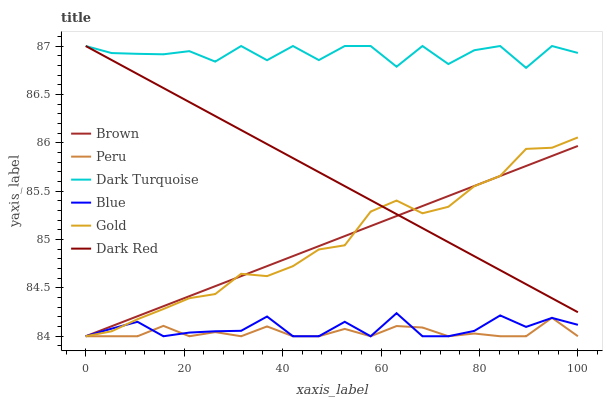Does Peru have the minimum area under the curve?
Answer yes or no. Yes. Does Dark Turquoise have the maximum area under the curve?
Answer yes or no. Yes. Does Brown have the minimum area under the curve?
Answer yes or no. No. Does Brown have the maximum area under the curve?
Answer yes or no. No. Is Brown the smoothest?
Answer yes or no. Yes. Is Dark Turquoise the roughest?
Answer yes or no. Yes. Is Gold the smoothest?
Answer yes or no. No. Is Gold the roughest?
Answer yes or no. No. Does Blue have the lowest value?
Answer yes or no. Yes. Does Dark Red have the lowest value?
Answer yes or no. No. Does Dark Turquoise have the highest value?
Answer yes or no. Yes. Does Brown have the highest value?
Answer yes or no. No. Is Blue less than Dark Turquoise?
Answer yes or no. Yes. Is Dark Turquoise greater than Gold?
Answer yes or no. Yes. Does Gold intersect Blue?
Answer yes or no. Yes. Is Gold less than Blue?
Answer yes or no. No. Is Gold greater than Blue?
Answer yes or no. No. Does Blue intersect Dark Turquoise?
Answer yes or no. No. 